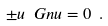Convert formula to latex. <formula><loc_0><loc_0><loc_500><loc_500>\pm u \ G n u = 0 \ .</formula> 